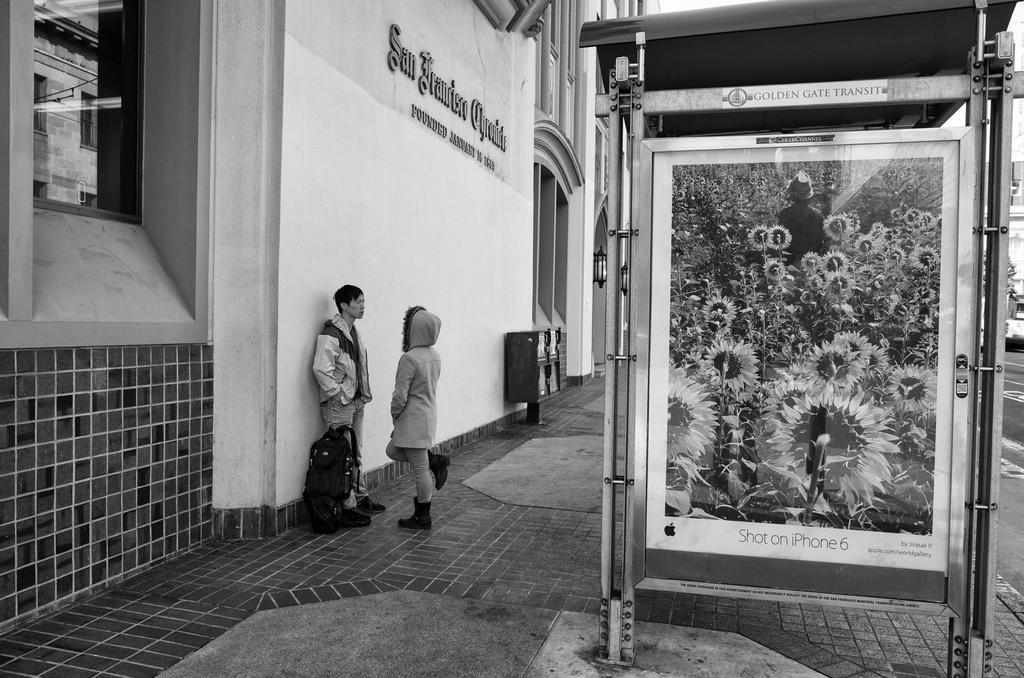Could you give a brief overview of what you see in this image? It looks like a black and white picture. We can see there are two people standing and on the path there is a bag. On the right side of the people there is a board and on the left side of the people there is a wall with a window, name board and other things. 